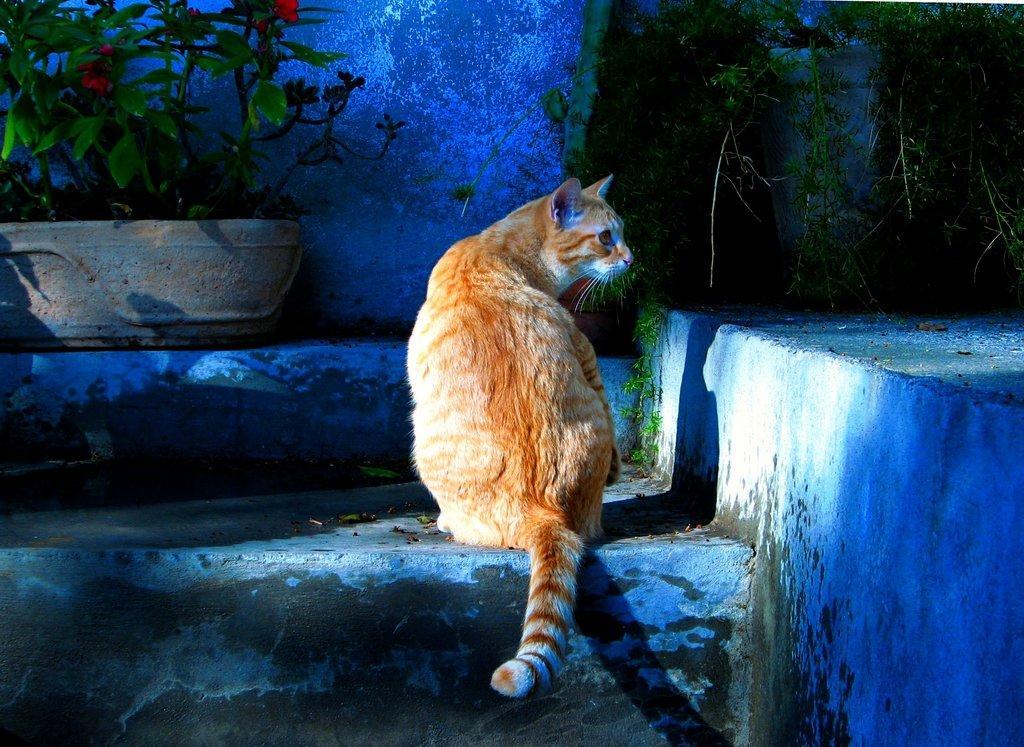Please provide a concise description of this image. Here we can see a cat. In-front of this cat there are plants and wall. This cat is looking right side of the image. 